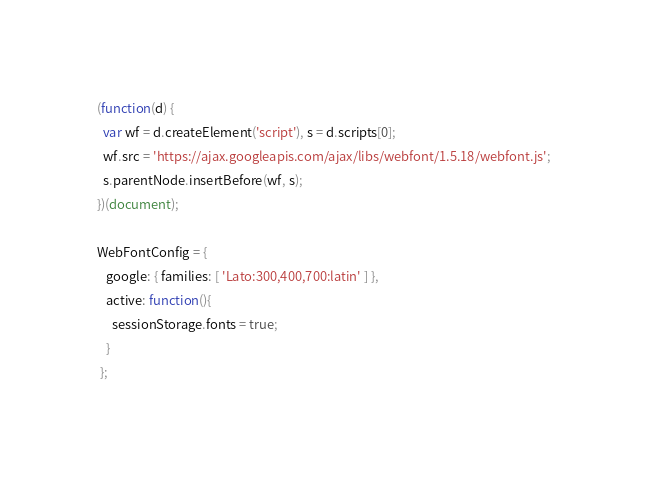<code> <loc_0><loc_0><loc_500><loc_500><_JavaScript_>(function(d) {
  var wf = d.createElement('script'), s = d.scripts[0];
  wf.src = 'https://ajax.googleapis.com/ajax/libs/webfont/1.5.18/webfont.js';
  s.parentNode.insertBefore(wf, s);
})(document);

WebFontConfig = {
   google: { families: [ 'Lato:300,400,700:latin' ] },
   active: function(){
     sessionStorage.fonts = true;
   }
 };
</code> 